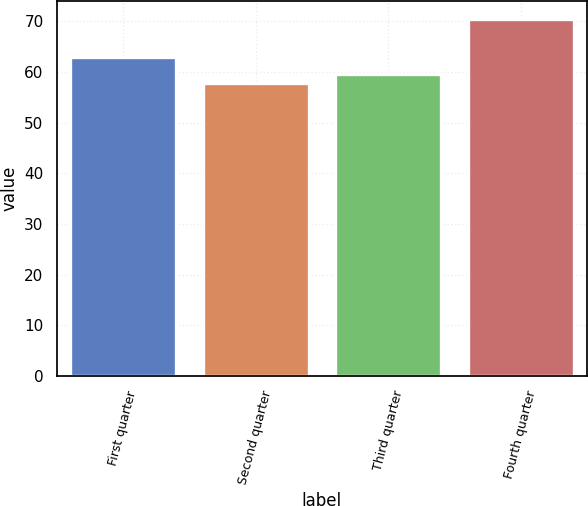Convert chart to OTSL. <chart><loc_0><loc_0><loc_500><loc_500><bar_chart><fcel>First quarter<fcel>Second quarter<fcel>Third quarter<fcel>Fourth quarter<nl><fcel>62.94<fcel>57.81<fcel>59.54<fcel>70.44<nl></chart> 